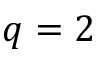<formula> <loc_0><loc_0><loc_500><loc_500>q = 2</formula> 